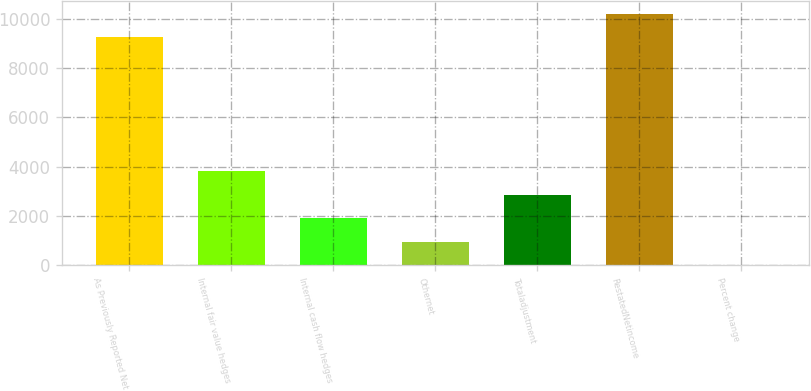<chart> <loc_0><loc_0><loc_500><loc_500><bar_chart><fcel>As Previously Reported Net<fcel>Internal fair value hedges<fcel>Internal cash flow hedges<fcel>Othernet<fcel>Totaladjustment<fcel>RestatedNetincome<fcel>Percent change<nl><fcel>9249<fcel>3823.18<fcel>1913.24<fcel>958.27<fcel>2868.21<fcel>10204<fcel>3.3<nl></chart> 